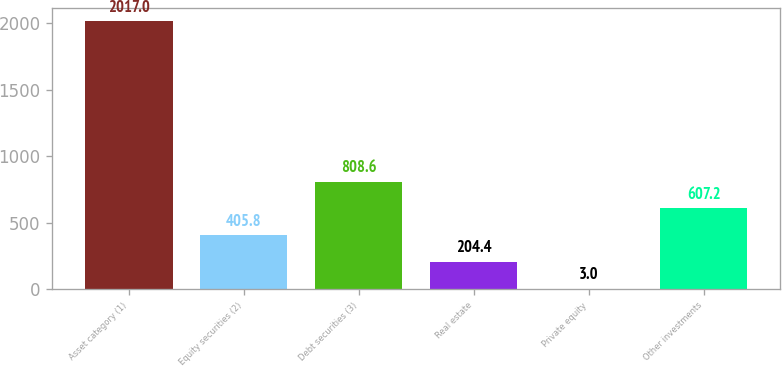<chart> <loc_0><loc_0><loc_500><loc_500><bar_chart><fcel>Asset category (1)<fcel>Equity securities (2)<fcel>Debt securities (3)<fcel>Real estate<fcel>Private equity<fcel>Other investments<nl><fcel>2017<fcel>405.8<fcel>808.6<fcel>204.4<fcel>3<fcel>607.2<nl></chart> 